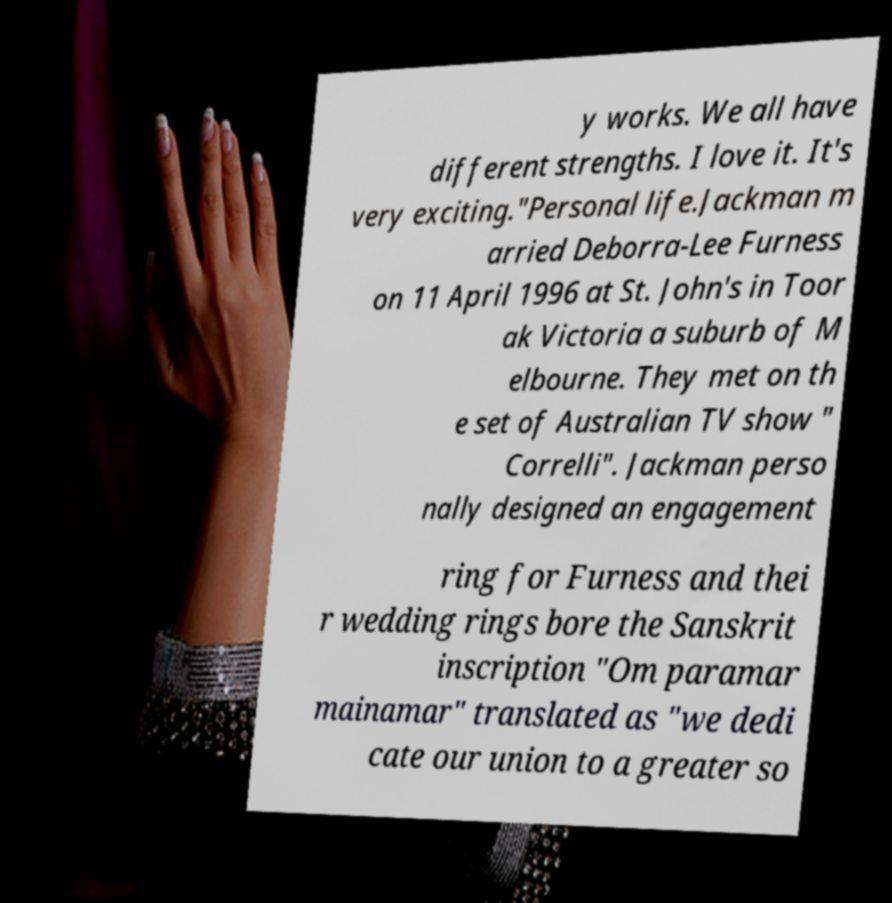Please read and relay the text visible in this image. What does it say? y works. We all have different strengths. I love it. It's very exciting."Personal life.Jackman m arried Deborra-Lee Furness on 11 April 1996 at St. John's in Toor ak Victoria a suburb of M elbourne. They met on th e set of Australian TV show " Correlli". Jackman perso nally designed an engagement ring for Furness and thei r wedding rings bore the Sanskrit inscription "Om paramar mainamar" translated as "we dedi cate our union to a greater so 